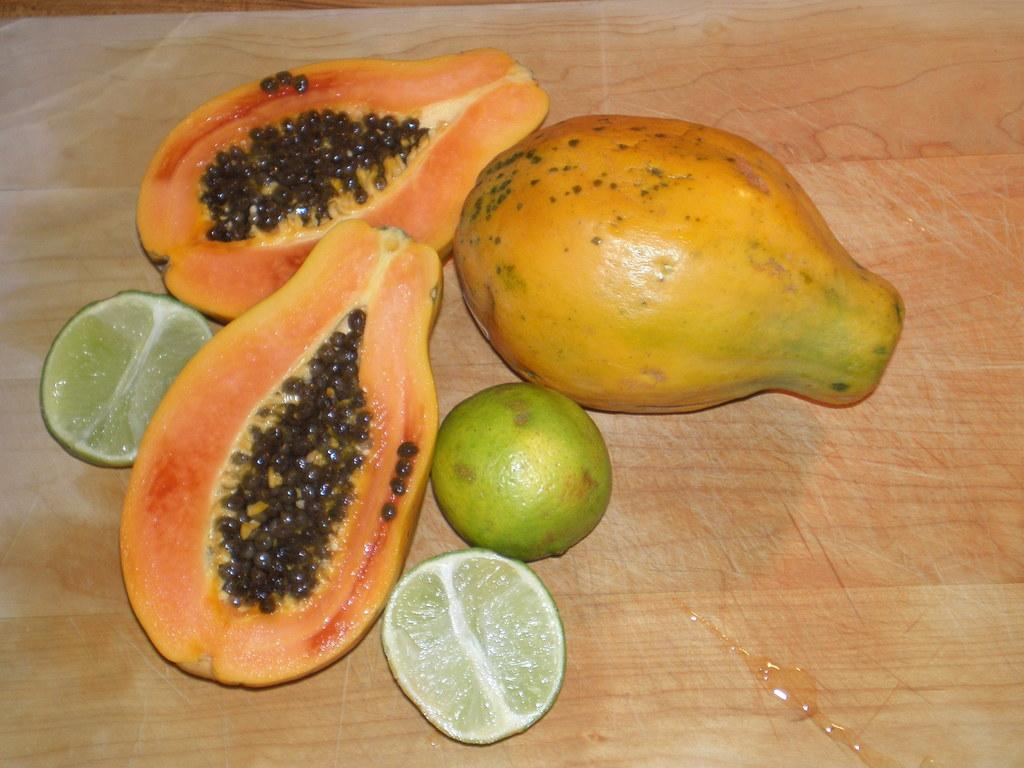What type of fruit can be seen in the image? There are papayas and lemons in the image. What is the wooden object that the papayas and lemons are on? The papayas and lemons are on a wooden object. What does the rabbit say to the son about the papayas in the image? There is no rabbit or son present in the image, and therefore no such conversation can be observed. 